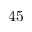Convert formula to latex. <formula><loc_0><loc_0><loc_500><loc_500>4 5</formula> 